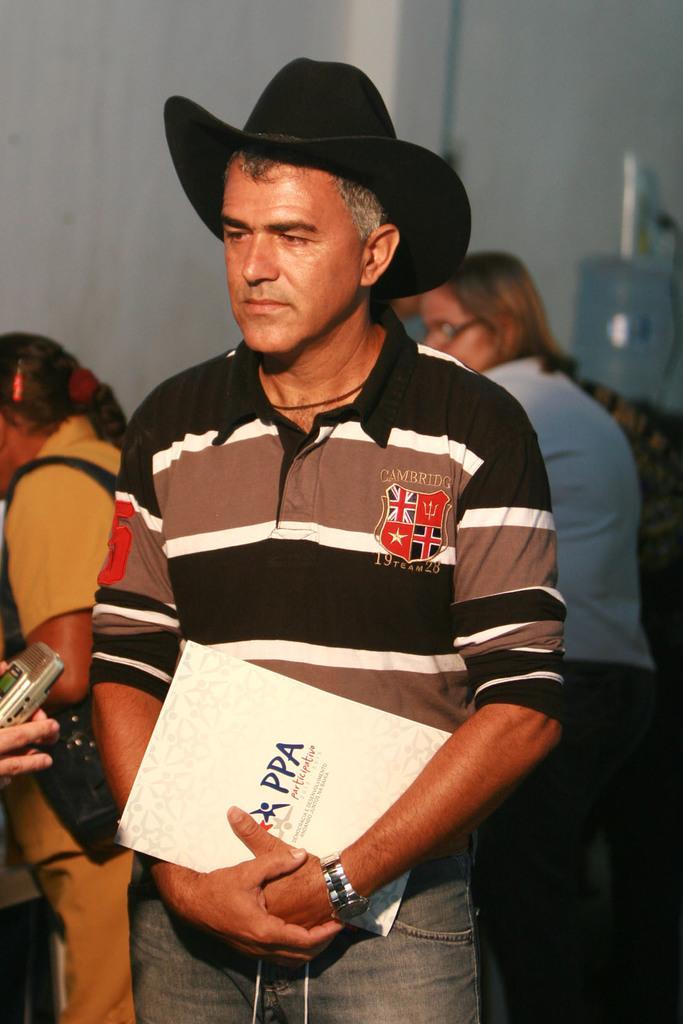Can you describe this image briefly? In this image I can see a man is standing by holding a book in his hand. He wore t-shirt, trouser and a hat, at the back side there are few people. 